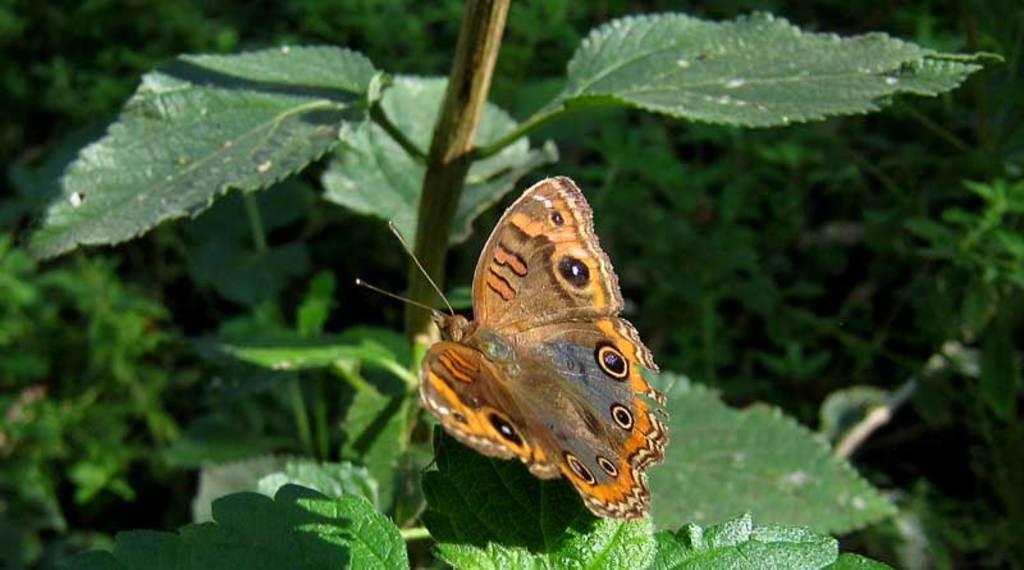In one or two sentences, can you explain what this image depicts? Here I can see a butterfly on a plant. I can see the plant in green color. In the background there are many plants. 